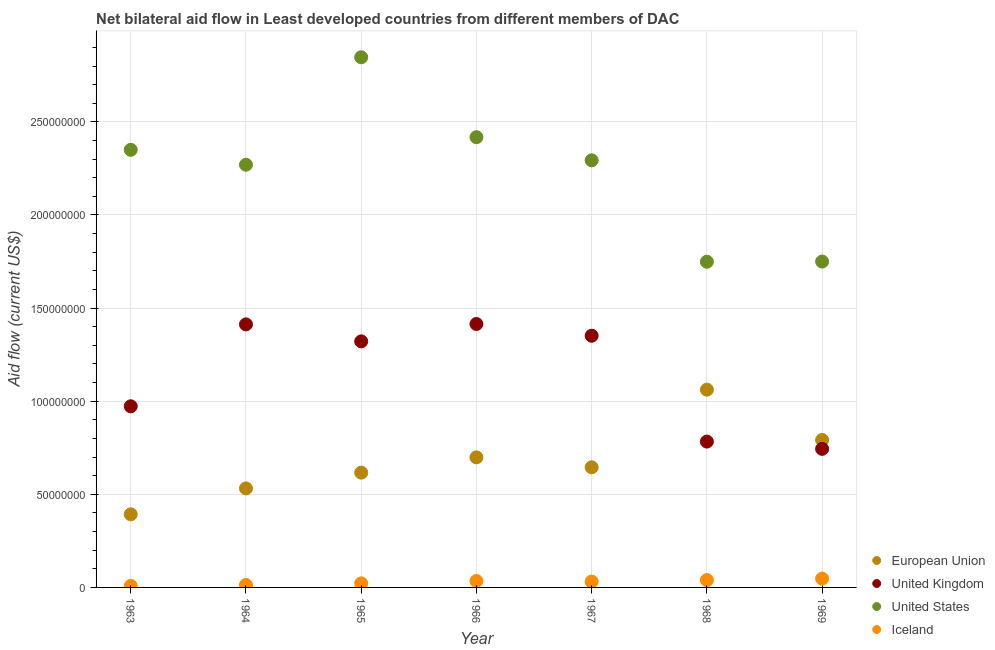What is the amount of aid given by uk in 1967?
Ensure brevity in your answer.  1.35e+08. Across all years, what is the maximum amount of aid given by iceland?
Keep it short and to the point. 4.74e+06. Across all years, what is the minimum amount of aid given by iceland?
Your response must be concise. 8.30e+05. In which year was the amount of aid given by us maximum?
Your answer should be compact. 1965. What is the total amount of aid given by us in the graph?
Provide a short and direct response. 1.57e+09. What is the difference between the amount of aid given by us in 1964 and that in 1969?
Make the answer very short. 5.20e+07. What is the difference between the amount of aid given by iceland in 1969 and the amount of aid given by uk in 1968?
Make the answer very short. -7.36e+07. What is the average amount of aid given by us per year?
Offer a terse response. 2.24e+08. In the year 1967, what is the difference between the amount of aid given by uk and amount of aid given by iceland?
Give a very brief answer. 1.32e+08. In how many years, is the amount of aid given by us greater than 130000000 US$?
Make the answer very short. 7. What is the ratio of the amount of aid given by uk in 1963 to that in 1968?
Your response must be concise. 1.24. What is the difference between the highest and the lowest amount of aid given by uk?
Offer a very short reply. 6.70e+07. In how many years, is the amount of aid given by uk greater than the average amount of aid given by uk taken over all years?
Your answer should be very brief. 4. Is the sum of the amount of aid given by eu in 1964 and 1969 greater than the maximum amount of aid given by iceland across all years?
Your answer should be very brief. Yes. Is it the case that in every year, the sum of the amount of aid given by eu and amount of aid given by uk is greater than the amount of aid given by us?
Your answer should be very brief. No. Does the amount of aid given by eu monotonically increase over the years?
Provide a succinct answer. No. Are the values on the major ticks of Y-axis written in scientific E-notation?
Your answer should be very brief. No. Where does the legend appear in the graph?
Offer a terse response. Bottom right. How many legend labels are there?
Provide a succinct answer. 4. What is the title of the graph?
Provide a short and direct response. Net bilateral aid flow in Least developed countries from different members of DAC. What is the label or title of the Y-axis?
Provide a short and direct response. Aid flow (current US$). What is the Aid flow (current US$) in European Union in 1963?
Your response must be concise. 3.93e+07. What is the Aid flow (current US$) of United Kingdom in 1963?
Your answer should be compact. 9.73e+07. What is the Aid flow (current US$) of United States in 1963?
Make the answer very short. 2.35e+08. What is the Aid flow (current US$) of Iceland in 1963?
Your answer should be very brief. 8.30e+05. What is the Aid flow (current US$) in European Union in 1964?
Your response must be concise. 5.32e+07. What is the Aid flow (current US$) in United Kingdom in 1964?
Provide a succinct answer. 1.41e+08. What is the Aid flow (current US$) in United States in 1964?
Give a very brief answer. 2.27e+08. What is the Aid flow (current US$) in Iceland in 1964?
Provide a succinct answer. 1.33e+06. What is the Aid flow (current US$) of European Union in 1965?
Offer a very short reply. 6.16e+07. What is the Aid flow (current US$) in United Kingdom in 1965?
Provide a succinct answer. 1.32e+08. What is the Aid flow (current US$) of United States in 1965?
Offer a very short reply. 2.85e+08. What is the Aid flow (current US$) of Iceland in 1965?
Your answer should be very brief. 2.18e+06. What is the Aid flow (current US$) of European Union in 1966?
Your answer should be compact. 6.99e+07. What is the Aid flow (current US$) in United Kingdom in 1966?
Offer a very short reply. 1.41e+08. What is the Aid flow (current US$) of United States in 1966?
Offer a very short reply. 2.42e+08. What is the Aid flow (current US$) of Iceland in 1966?
Offer a very short reply. 3.46e+06. What is the Aid flow (current US$) of European Union in 1967?
Keep it short and to the point. 6.45e+07. What is the Aid flow (current US$) in United Kingdom in 1967?
Give a very brief answer. 1.35e+08. What is the Aid flow (current US$) of United States in 1967?
Offer a very short reply. 2.29e+08. What is the Aid flow (current US$) in Iceland in 1967?
Your answer should be very brief. 3.12e+06. What is the Aid flow (current US$) of European Union in 1968?
Provide a succinct answer. 1.06e+08. What is the Aid flow (current US$) in United Kingdom in 1968?
Your answer should be very brief. 7.83e+07. What is the Aid flow (current US$) of United States in 1968?
Give a very brief answer. 1.75e+08. What is the Aid flow (current US$) in Iceland in 1968?
Offer a very short reply. 3.94e+06. What is the Aid flow (current US$) of European Union in 1969?
Ensure brevity in your answer.  7.92e+07. What is the Aid flow (current US$) of United Kingdom in 1969?
Make the answer very short. 7.44e+07. What is the Aid flow (current US$) in United States in 1969?
Your answer should be compact. 1.75e+08. What is the Aid flow (current US$) in Iceland in 1969?
Provide a succinct answer. 4.74e+06. Across all years, what is the maximum Aid flow (current US$) in European Union?
Provide a short and direct response. 1.06e+08. Across all years, what is the maximum Aid flow (current US$) in United Kingdom?
Provide a short and direct response. 1.41e+08. Across all years, what is the maximum Aid flow (current US$) of United States?
Provide a short and direct response. 2.85e+08. Across all years, what is the maximum Aid flow (current US$) in Iceland?
Provide a short and direct response. 4.74e+06. Across all years, what is the minimum Aid flow (current US$) in European Union?
Your answer should be very brief. 3.93e+07. Across all years, what is the minimum Aid flow (current US$) of United Kingdom?
Make the answer very short. 7.44e+07. Across all years, what is the minimum Aid flow (current US$) of United States?
Give a very brief answer. 1.75e+08. Across all years, what is the minimum Aid flow (current US$) in Iceland?
Your response must be concise. 8.30e+05. What is the total Aid flow (current US$) of European Union in the graph?
Your answer should be compact. 4.74e+08. What is the total Aid flow (current US$) of United Kingdom in the graph?
Provide a short and direct response. 8.00e+08. What is the total Aid flow (current US$) in United States in the graph?
Ensure brevity in your answer.  1.57e+09. What is the total Aid flow (current US$) in Iceland in the graph?
Offer a terse response. 1.96e+07. What is the difference between the Aid flow (current US$) of European Union in 1963 and that in 1964?
Ensure brevity in your answer.  -1.39e+07. What is the difference between the Aid flow (current US$) of United Kingdom in 1963 and that in 1964?
Provide a short and direct response. -4.40e+07. What is the difference between the Aid flow (current US$) in United States in 1963 and that in 1964?
Your answer should be compact. 8.00e+06. What is the difference between the Aid flow (current US$) of Iceland in 1963 and that in 1964?
Give a very brief answer. -5.00e+05. What is the difference between the Aid flow (current US$) of European Union in 1963 and that in 1965?
Offer a terse response. -2.24e+07. What is the difference between the Aid flow (current US$) in United Kingdom in 1963 and that in 1965?
Provide a short and direct response. -3.49e+07. What is the difference between the Aid flow (current US$) in United States in 1963 and that in 1965?
Make the answer very short. -4.97e+07. What is the difference between the Aid flow (current US$) of Iceland in 1963 and that in 1965?
Your answer should be very brief. -1.35e+06. What is the difference between the Aid flow (current US$) of European Union in 1963 and that in 1966?
Keep it short and to the point. -3.06e+07. What is the difference between the Aid flow (current US$) in United Kingdom in 1963 and that in 1966?
Offer a terse response. -4.42e+07. What is the difference between the Aid flow (current US$) of United States in 1963 and that in 1966?
Your answer should be very brief. -6.78e+06. What is the difference between the Aid flow (current US$) of Iceland in 1963 and that in 1966?
Make the answer very short. -2.63e+06. What is the difference between the Aid flow (current US$) of European Union in 1963 and that in 1967?
Your response must be concise. -2.52e+07. What is the difference between the Aid flow (current US$) of United Kingdom in 1963 and that in 1967?
Your response must be concise. -3.79e+07. What is the difference between the Aid flow (current US$) of United States in 1963 and that in 1967?
Offer a very short reply. 5.63e+06. What is the difference between the Aid flow (current US$) of Iceland in 1963 and that in 1967?
Make the answer very short. -2.29e+06. What is the difference between the Aid flow (current US$) in European Union in 1963 and that in 1968?
Provide a succinct answer. -6.69e+07. What is the difference between the Aid flow (current US$) of United Kingdom in 1963 and that in 1968?
Your answer should be compact. 1.90e+07. What is the difference between the Aid flow (current US$) of United States in 1963 and that in 1968?
Offer a very short reply. 6.01e+07. What is the difference between the Aid flow (current US$) in Iceland in 1963 and that in 1968?
Keep it short and to the point. -3.11e+06. What is the difference between the Aid flow (current US$) in European Union in 1963 and that in 1969?
Ensure brevity in your answer.  -3.99e+07. What is the difference between the Aid flow (current US$) of United Kingdom in 1963 and that in 1969?
Make the answer very short. 2.28e+07. What is the difference between the Aid flow (current US$) in United States in 1963 and that in 1969?
Ensure brevity in your answer.  6.00e+07. What is the difference between the Aid flow (current US$) of Iceland in 1963 and that in 1969?
Provide a short and direct response. -3.91e+06. What is the difference between the Aid flow (current US$) in European Union in 1964 and that in 1965?
Offer a terse response. -8.46e+06. What is the difference between the Aid flow (current US$) in United Kingdom in 1964 and that in 1965?
Give a very brief answer. 9.12e+06. What is the difference between the Aid flow (current US$) in United States in 1964 and that in 1965?
Give a very brief answer. -5.77e+07. What is the difference between the Aid flow (current US$) in Iceland in 1964 and that in 1965?
Your answer should be very brief. -8.50e+05. What is the difference between the Aid flow (current US$) of European Union in 1964 and that in 1966?
Provide a short and direct response. -1.67e+07. What is the difference between the Aid flow (current US$) of United States in 1964 and that in 1966?
Make the answer very short. -1.48e+07. What is the difference between the Aid flow (current US$) of Iceland in 1964 and that in 1966?
Provide a succinct answer. -2.13e+06. What is the difference between the Aid flow (current US$) of European Union in 1964 and that in 1967?
Ensure brevity in your answer.  -1.13e+07. What is the difference between the Aid flow (current US$) in United Kingdom in 1964 and that in 1967?
Provide a succinct answer. 6.10e+06. What is the difference between the Aid flow (current US$) in United States in 1964 and that in 1967?
Keep it short and to the point. -2.37e+06. What is the difference between the Aid flow (current US$) of Iceland in 1964 and that in 1967?
Offer a very short reply. -1.79e+06. What is the difference between the Aid flow (current US$) of European Union in 1964 and that in 1968?
Your answer should be compact. -5.30e+07. What is the difference between the Aid flow (current US$) of United Kingdom in 1964 and that in 1968?
Offer a very short reply. 6.29e+07. What is the difference between the Aid flow (current US$) in United States in 1964 and that in 1968?
Give a very brief answer. 5.21e+07. What is the difference between the Aid flow (current US$) of Iceland in 1964 and that in 1968?
Provide a short and direct response. -2.61e+06. What is the difference between the Aid flow (current US$) in European Union in 1964 and that in 1969?
Ensure brevity in your answer.  -2.60e+07. What is the difference between the Aid flow (current US$) of United Kingdom in 1964 and that in 1969?
Your answer should be very brief. 6.68e+07. What is the difference between the Aid flow (current US$) in United States in 1964 and that in 1969?
Your answer should be very brief. 5.20e+07. What is the difference between the Aid flow (current US$) of Iceland in 1964 and that in 1969?
Make the answer very short. -3.41e+06. What is the difference between the Aid flow (current US$) of European Union in 1965 and that in 1966?
Your answer should be compact. -8.22e+06. What is the difference between the Aid flow (current US$) of United Kingdom in 1965 and that in 1966?
Your answer should be compact. -9.33e+06. What is the difference between the Aid flow (current US$) in United States in 1965 and that in 1966?
Offer a terse response. 4.29e+07. What is the difference between the Aid flow (current US$) in Iceland in 1965 and that in 1966?
Make the answer very short. -1.28e+06. What is the difference between the Aid flow (current US$) of European Union in 1965 and that in 1967?
Give a very brief answer. -2.87e+06. What is the difference between the Aid flow (current US$) of United Kingdom in 1965 and that in 1967?
Your answer should be compact. -3.02e+06. What is the difference between the Aid flow (current US$) of United States in 1965 and that in 1967?
Provide a short and direct response. 5.53e+07. What is the difference between the Aid flow (current US$) in Iceland in 1965 and that in 1967?
Provide a short and direct response. -9.40e+05. What is the difference between the Aid flow (current US$) in European Union in 1965 and that in 1968?
Offer a terse response. -4.46e+07. What is the difference between the Aid flow (current US$) in United Kingdom in 1965 and that in 1968?
Your response must be concise. 5.38e+07. What is the difference between the Aid flow (current US$) of United States in 1965 and that in 1968?
Keep it short and to the point. 1.10e+08. What is the difference between the Aid flow (current US$) of Iceland in 1965 and that in 1968?
Offer a terse response. -1.76e+06. What is the difference between the Aid flow (current US$) in European Union in 1965 and that in 1969?
Provide a succinct answer. -1.75e+07. What is the difference between the Aid flow (current US$) of United Kingdom in 1965 and that in 1969?
Provide a short and direct response. 5.77e+07. What is the difference between the Aid flow (current US$) in United States in 1965 and that in 1969?
Give a very brief answer. 1.10e+08. What is the difference between the Aid flow (current US$) of Iceland in 1965 and that in 1969?
Your response must be concise. -2.56e+06. What is the difference between the Aid flow (current US$) of European Union in 1966 and that in 1967?
Your answer should be compact. 5.35e+06. What is the difference between the Aid flow (current US$) of United Kingdom in 1966 and that in 1967?
Provide a short and direct response. 6.31e+06. What is the difference between the Aid flow (current US$) in United States in 1966 and that in 1967?
Your response must be concise. 1.24e+07. What is the difference between the Aid flow (current US$) in Iceland in 1966 and that in 1967?
Provide a short and direct response. 3.40e+05. What is the difference between the Aid flow (current US$) in European Union in 1966 and that in 1968?
Offer a very short reply. -3.63e+07. What is the difference between the Aid flow (current US$) in United Kingdom in 1966 and that in 1968?
Your answer should be compact. 6.32e+07. What is the difference between the Aid flow (current US$) of United States in 1966 and that in 1968?
Provide a short and direct response. 6.69e+07. What is the difference between the Aid flow (current US$) in Iceland in 1966 and that in 1968?
Offer a very short reply. -4.80e+05. What is the difference between the Aid flow (current US$) of European Union in 1966 and that in 1969?
Your answer should be compact. -9.32e+06. What is the difference between the Aid flow (current US$) of United Kingdom in 1966 and that in 1969?
Your answer should be very brief. 6.70e+07. What is the difference between the Aid flow (current US$) in United States in 1966 and that in 1969?
Ensure brevity in your answer.  6.68e+07. What is the difference between the Aid flow (current US$) in Iceland in 1966 and that in 1969?
Provide a succinct answer. -1.28e+06. What is the difference between the Aid flow (current US$) of European Union in 1967 and that in 1968?
Your answer should be very brief. -4.17e+07. What is the difference between the Aid flow (current US$) of United Kingdom in 1967 and that in 1968?
Keep it short and to the point. 5.68e+07. What is the difference between the Aid flow (current US$) in United States in 1967 and that in 1968?
Provide a succinct answer. 5.45e+07. What is the difference between the Aid flow (current US$) of Iceland in 1967 and that in 1968?
Ensure brevity in your answer.  -8.20e+05. What is the difference between the Aid flow (current US$) of European Union in 1967 and that in 1969?
Your response must be concise. -1.47e+07. What is the difference between the Aid flow (current US$) in United Kingdom in 1967 and that in 1969?
Offer a very short reply. 6.07e+07. What is the difference between the Aid flow (current US$) of United States in 1967 and that in 1969?
Provide a short and direct response. 5.44e+07. What is the difference between the Aid flow (current US$) of Iceland in 1967 and that in 1969?
Provide a short and direct response. -1.62e+06. What is the difference between the Aid flow (current US$) in European Union in 1968 and that in 1969?
Ensure brevity in your answer.  2.70e+07. What is the difference between the Aid flow (current US$) of United Kingdom in 1968 and that in 1969?
Ensure brevity in your answer.  3.90e+06. What is the difference between the Aid flow (current US$) in United States in 1968 and that in 1969?
Make the answer very short. -1.00e+05. What is the difference between the Aid flow (current US$) of Iceland in 1968 and that in 1969?
Make the answer very short. -8.00e+05. What is the difference between the Aid flow (current US$) in European Union in 1963 and the Aid flow (current US$) in United Kingdom in 1964?
Your response must be concise. -1.02e+08. What is the difference between the Aid flow (current US$) in European Union in 1963 and the Aid flow (current US$) in United States in 1964?
Offer a very short reply. -1.88e+08. What is the difference between the Aid flow (current US$) of European Union in 1963 and the Aid flow (current US$) of Iceland in 1964?
Make the answer very short. 3.79e+07. What is the difference between the Aid flow (current US$) in United Kingdom in 1963 and the Aid flow (current US$) in United States in 1964?
Offer a very short reply. -1.30e+08. What is the difference between the Aid flow (current US$) of United Kingdom in 1963 and the Aid flow (current US$) of Iceland in 1964?
Ensure brevity in your answer.  9.59e+07. What is the difference between the Aid flow (current US$) of United States in 1963 and the Aid flow (current US$) of Iceland in 1964?
Keep it short and to the point. 2.34e+08. What is the difference between the Aid flow (current US$) of European Union in 1963 and the Aid flow (current US$) of United Kingdom in 1965?
Your answer should be very brief. -9.29e+07. What is the difference between the Aid flow (current US$) of European Union in 1963 and the Aid flow (current US$) of United States in 1965?
Your answer should be very brief. -2.45e+08. What is the difference between the Aid flow (current US$) in European Union in 1963 and the Aid flow (current US$) in Iceland in 1965?
Give a very brief answer. 3.71e+07. What is the difference between the Aid flow (current US$) of United Kingdom in 1963 and the Aid flow (current US$) of United States in 1965?
Give a very brief answer. -1.87e+08. What is the difference between the Aid flow (current US$) of United Kingdom in 1963 and the Aid flow (current US$) of Iceland in 1965?
Offer a terse response. 9.51e+07. What is the difference between the Aid flow (current US$) of United States in 1963 and the Aid flow (current US$) of Iceland in 1965?
Your answer should be compact. 2.33e+08. What is the difference between the Aid flow (current US$) of European Union in 1963 and the Aid flow (current US$) of United Kingdom in 1966?
Make the answer very short. -1.02e+08. What is the difference between the Aid flow (current US$) in European Union in 1963 and the Aid flow (current US$) in United States in 1966?
Your answer should be very brief. -2.03e+08. What is the difference between the Aid flow (current US$) in European Union in 1963 and the Aid flow (current US$) in Iceland in 1966?
Offer a very short reply. 3.58e+07. What is the difference between the Aid flow (current US$) in United Kingdom in 1963 and the Aid flow (current US$) in United States in 1966?
Your response must be concise. -1.45e+08. What is the difference between the Aid flow (current US$) in United Kingdom in 1963 and the Aid flow (current US$) in Iceland in 1966?
Provide a succinct answer. 9.38e+07. What is the difference between the Aid flow (current US$) of United States in 1963 and the Aid flow (current US$) of Iceland in 1966?
Keep it short and to the point. 2.32e+08. What is the difference between the Aid flow (current US$) in European Union in 1963 and the Aid flow (current US$) in United Kingdom in 1967?
Your response must be concise. -9.59e+07. What is the difference between the Aid flow (current US$) of European Union in 1963 and the Aid flow (current US$) of United States in 1967?
Your answer should be compact. -1.90e+08. What is the difference between the Aid flow (current US$) in European Union in 1963 and the Aid flow (current US$) in Iceland in 1967?
Keep it short and to the point. 3.61e+07. What is the difference between the Aid flow (current US$) of United Kingdom in 1963 and the Aid flow (current US$) of United States in 1967?
Your answer should be very brief. -1.32e+08. What is the difference between the Aid flow (current US$) of United Kingdom in 1963 and the Aid flow (current US$) of Iceland in 1967?
Provide a short and direct response. 9.42e+07. What is the difference between the Aid flow (current US$) of United States in 1963 and the Aid flow (current US$) of Iceland in 1967?
Ensure brevity in your answer.  2.32e+08. What is the difference between the Aid flow (current US$) of European Union in 1963 and the Aid flow (current US$) of United Kingdom in 1968?
Ensure brevity in your answer.  -3.91e+07. What is the difference between the Aid flow (current US$) in European Union in 1963 and the Aid flow (current US$) in United States in 1968?
Offer a very short reply. -1.36e+08. What is the difference between the Aid flow (current US$) in European Union in 1963 and the Aid flow (current US$) in Iceland in 1968?
Offer a terse response. 3.53e+07. What is the difference between the Aid flow (current US$) of United Kingdom in 1963 and the Aid flow (current US$) of United States in 1968?
Offer a very short reply. -7.76e+07. What is the difference between the Aid flow (current US$) of United Kingdom in 1963 and the Aid flow (current US$) of Iceland in 1968?
Ensure brevity in your answer.  9.33e+07. What is the difference between the Aid flow (current US$) of United States in 1963 and the Aid flow (current US$) of Iceland in 1968?
Offer a very short reply. 2.31e+08. What is the difference between the Aid flow (current US$) of European Union in 1963 and the Aid flow (current US$) of United Kingdom in 1969?
Offer a very short reply. -3.52e+07. What is the difference between the Aid flow (current US$) of European Union in 1963 and the Aid flow (current US$) of United States in 1969?
Make the answer very short. -1.36e+08. What is the difference between the Aid flow (current US$) of European Union in 1963 and the Aid flow (current US$) of Iceland in 1969?
Provide a succinct answer. 3.45e+07. What is the difference between the Aid flow (current US$) in United Kingdom in 1963 and the Aid flow (current US$) in United States in 1969?
Your answer should be compact. -7.77e+07. What is the difference between the Aid flow (current US$) in United Kingdom in 1963 and the Aid flow (current US$) in Iceland in 1969?
Keep it short and to the point. 9.25e+07. What is the difference between the Aid flow (current US$) in United States in 1963 and the Aid flow (current US$) in Iceland in 1969?
Your answer should be very brief. 2.30e+08. What is the difference between the Aid flow (current US$) in European Union in 1964 and the Aid flow (current US$) in United Kingdom in 1965?
Provide a succinct answer. -7.90e+07. What is the difference between the Aid flow (current US$) of European Union in 1964 and the Aid flow (current US$) of United States in 1965?
Your response must be concise. -2.32e+08. What is the difference between the Aid flow (current US$) of European Union in 1964 and the Aid flow (current US$) of Iceland in 1965?
Provide a succinct answer. 5.10e+07. What is the difference between the Aid flow (current US$) in United Kingdom in 1964 and the Aid flow (current US$) in United States in 1965?
Keep it short and to the point. -1.43e+08. What is the difference between the Aid flow (current US$) of United Kingdom in 1964 and the Aid flow (current US$) of Iceland in 1965?
Your answer should be very brief. 1.39e+08. What is the difference between the Aid flow (current US$) of United States in 1964 and the Aid flow (current US$) of Iceland in 1965?
Keep it short and to the point. 2.25e+08. What is the difference between the Aid flow (current US$) in European Union in 1964 and the Aid flow (current US$) in United Kingdom in 1966?
Provide a short and direct response. -8.83e+07. What is the difference between the Aid flow (current US$) in European Union in 1964 and the Aid flow (current US$) in United States in 1966?
Offer a terse response. -1.89e+08. What is the difference between the Aid flow (current US$) in European Union in 1964 and the Aid flow (current US$) in Iceland in 1966?
Provide a short and direct response. 4.97e+07. What is the difference between the Aid flow (current US$) of United Kingdom in 1964 and the Aid flow (current US$) of United States in 1966?
Your answer should be compact. -1.01e+08. What is the difference between the Aid flow (current US$) of United Kingdom in 1964 and the Aid flow (current US$) of Iceland in 1966?
Offer a very short reply. 1.38e+08. What is the difference between the Aid flow (current US$) in United States in 1964 and the Aid flow (current US$) in Iceland in 1966?
Your answer should be compact. 2.24e+08. What is the difference between the Aid flow (current US$) in European Union in 1964 and the Aid flow (current US$) in United Kingdom in 1967?
Provide a short and direct response. -8.20e+07. What is the difference between the Aid flow (current US$) of European Union in 1964 and the Aid flow (current US$) of United States in 1967?
Your answer should be compact. -1.76e+08. What is the difference between the Aid flow (current US$) in European Union in 1964 and the Aid flow (current US$) in Iceland in 1967?
Offer a very short reply. 5.01e+07. What is the difference between the Aid flow (current US$) of United Kingdom in 1964 and the Aid flow (current US$) of United States in 1967?
Provide a succinct answer. -8.81e+07. What is the difference between the Aid flow (current US$) in United Kingdom in 1964 and the Aid flow (current US$) in Iceland in 1967?
Ensure brevity in your answer.  1.38e+08. What is the difference between the Aid flow (current US$) of United States in 1964 and the Aid flow (current US$) of Iceland in 1967?
Make the answer very short. 2.24e+08. What is the difference between the Aid flow (current US$) in European Union in 1964 and the Aid flow (current US$) in United Kingdom in 1968?
Offer a terse response. -2.51e+07. What is the difference between the Aid flow (current US$) of European Union in 1964 and the Aid flow (current US$) of United States in 1968?
Offer a very short reply. -1.22e+08. What is the difference between the Aid flow (current US$) in European Union in 1964 and the Aid flow (current US$) in Iceland in 1968?
Your answer should be compact. 4.92e+07. What is the difference between the Aid flow (current US$) in United Kingdom in 1964 and the Aid flow (current US$) in United States in 1968?
Make the answer very short. -3.36e+07. What is the difference between the Aid flow (current US$) of United Kingdom in 1964 and the Aid flow (current US$) of Iceland in 1968?
Offer a terse response. 1.37e+08. What is the difference between the Aid flow (current US$) of United States in 1964 and the Aid flow (current US$) of Iceland in 1968?
Provide a short and direct response. 2.23e+08. What is the difference between the Aid flow (current US$) in European Union in 1964 and the Aid flow (current US$) in United Kingdom in 1969?
Your answer should be compact. -2.12e+07. What is the difference between the Aid flow (current US$) in European Union in 1964 and the Aid flow (current US$) in United States in 1969?
Offer a terse response. -1.22e+08. What is the difference between the Aid flow (current US$) of European Union in 1964 and the Aid flow (current US$) of Iceland in 1969?
Your answer should be very brief. 4.84e+07. What is the difference between the Aid flow (current US$) in United Kingdom in 1964 and the Aid flow (current US$) in United States in 1969?
Offer a terse response. -3.37e+07. What is the difference between the Aid flow (current US$) of United Kingdom in 1964 and the Aid flow (current US$) of Iceland in 1969?
Make the answer very short. 1.37e+08. What is the difference between the Aid flow (current US$) in United States in 1964 and the Aid flow (current US$) in Iceland in 1969?
Give a very brief answer. 2.22e+08. What is the difference between the Aid flow (current US$) of European Union in 1965 and the Aid flow (current US$) of United Kingdom in 1966?
Ensure brevity in your answer.  -7.98e+07. What is the difference between the Aid flow (current US$) in European Union in 1965 and the Aid flow (current US$) in United States in 1966?
Your answer should be compact. -1.80e+08. What is the difference between the Aid flow (current US$) in European Union in 1965 and the Aid flow (current US$) in Iceland in 1966?
Your response must be concise. 5.82e+07. What is the difference between the Aid flow (current US$) in United Kingdom in 1965 and the Aid flow (current US$) in United States in 1966?
Offer a terse response. -1.10e+08. What is the difference between the Aid flow (current US$) in United Kingdom in 1965 and the Aid flow (current US$) in Iceland in 1966?
Your answer should be compact. 1.29e+08. What is the difference between the Aid flow (current US$) in United States in 1965 and the Aid flow (current US$) in Iceland in 1966?
Ensure brevity in your answer.  2.81e+08. What is the difference between the Aid flow (current US$) of European Union in 1965 and the Aid flow (current US$) of United Kingdom in 1967?
Provide a succinct answer. -7.35e+07. What is the difference between the Aid flow (current US$) of European Union in 1965 and the Aid flow (current US$) of United States in 1967?
Ensure brevity in your answer.  -1.68e+08. What is the difference between the Aid flow (current US$) of European Union in 1965 and the Aid flow (current US$) of Iceland in 1967?
Your answer should be very brief. 5.85e+07. What is the difference between the Aid flow (current US$) of United Kingdom in 1965 and the Aid flow (current US$) of United States in 1967?
Keep it short and to the point. -9.72e+07. What is the difference between the Aid flow (current US$) of United Kingdom in 1965 and the Aid flow (current US$) of Iceland in 1967?
Give a very brief answer. 1.29e+08. What is the difference between the Aid flow (current US$) in United States in 1965 and the Aid flow (current US$) in Iceland in 1967?
Give a very brief answer. 2.82e+08. What is the difference between the Aid flow (current US$) of European Union in 1965 and the Aid flow (current US$) of United Kingdom in 1968?
Give a very brief answer. -1.67e+07. What is the difference between the Aid flow (current US$) in European Union in 1965 and the Aid flow (current US$) in United States in 1968?
Provide a succinct answer. -1.13e+08. What is the difference between the Aid flow (current US$) in European Union in 1965 and the Aid flow (current US$) in Iceland in 1968?
Keep it short and to the point. 5.77e+07. What is the difference between the Aid flow (current US$) of United Kingdom in 1965 and the Aid flow (current US$) of United States in 1968?
Offer a very short reply. -4.28e+07. What is the difference between the Aid flow (current US$) in United Kingdom in 1965 and the Aid flow (current US$) in Iceland in 1968?
Make the answer very short. 1.28e+08. What is the difference between the Aid flow (current US$) of United States in 1965 and the Aid flow (current US$) of Iceland in 1968?
Your response must be concise. 2.81e+08. What is the difference between the Aid flow (current US$) of European Union in 1965 and the Aid flow (current US$) of United Kingdom in 1969?
Offer a very short reply. -1.28e+07. What is the difference between the Aid flow (current US$) of European Union in 1965 and the Aid flow (current US$) of United States in 1969?
Provide a succinct answer. -1.13e+08. What is the difference between the Aid flow (current US$) of European Union in 1965 and the Aid flow (current US$) of Iceland in 1969?
Give a very brief answer. 5.69e+07. What is the difference between the Aid flow (current US$) in United Kingdom in 1965 and the Aid flow (current US$) in United States in 1969?
Ensure brevity in your answer.  -4.29e+07. What is the difference between the Aid flow (current US$) of United Kingdom in 1965 and the Aid flow (current US$) of Iceland in 1969?
Keep it short and to the point. 1.27e+08. What is the difference between the Aid flow (current US$) of United States in 1965 and the Aid flow (current US$) of Iceland in 1969?
Your answer should be very brief. 2.80e+08. What is the difference between the Aid flow (current US$) of European Union in 1966 and the Aid flow (current US$) of United Kingdom in 1967?
Your response must be concise. -6.53e+07. What is the difference between the Aid flow (current US$) of European Union in 1966 and the Aid flow (current US$) of United States in 1967?
Keep it short and to the point. -1.60e+08. What is the difference between the Aid flow (current US$) in European Union in 1966 and the Aid flow (current US$) in Iceland in 1967?
Keep it short and to the point. 6.67e+07. What is the difference between the Aid flow (current US$) in United Kingdom in 1966 and the Aid flow (current US$) in United States in 1967?
Your answer should be compact. -8.79e+07. What is the difference between the Aid flow (current US$) of United Kingdom in 1966 and the Aid flow (current US$) of Iceland in 1967?
Ensure brevity in your answer.  1.38e+08. What is the difference between the Aid flow (current US$) of United States in 1966 and the Aid flow (current US$) of Iceland in 1967?
Ensure brevity in your answer.  2.39e+08. What is the difference between the Aid flow (current US$) of European Union in 1966 and the Aid flow (current US$) of United Kingdom in 1968?
Offer a terse response. -8.46e+06. What is the difference between the Aid flow (current US$) of European Union in 1966 and the Aid flow (current US$) of United States in 1968?
Offer a very short reply. -1.05e+08. What is the difference between the Aid flow (current US$) of European Union in 1966 and the Aid flow (current US$) of Iceland in 1968?
Your answer should be very brief. 6.59e+07. What is the difference between the Aid flow (current US$) in United Kingdom in 1966 and the Aid flow (current US$) in United States in 1968?
Offer a terse response. -3.34e+07. What is the difference between the Aid flow (current US$) of United Kingdom in 1966 and the Aid flow (current US$) of Iceland in 1968?
Ensure brevity in your answer.  1.38e+08. What is the difference between the Aid flow (current US$) in United States in 1966 and the Aid flow (current US$) in Iceland in 1968?
Your answer should be very brief. 2.38e+08. What is the difference between the Aid flow (current US$) in European Union in 1966 and the Aid flow (current US$) in United Kingdom in 1969?
Make the answer very short. -4.56e+06. What is the difference between the Aid flow (current US$) in European Union in 1966 and the Aid flow (current US$) in United States in 1969?
Provide a succinct answer. -1.05e+08. What is the difference between the Aid flow (current US$) in European Union in 1966 and the Aid flow (current US$) in Iceland in 1969?
Provide a short and direct response. 6.51e+07. What is the difference between the Aid flow (current US$) of United Kingdom in 1966 and the Aid flow (current US$) of United States in 1969?
Provide a succinct answer. -3.35e+07. What is the difference between the Aid flow (current US$) of United Kingdom in 1966 and the Aid flow (current US$) of Iceland in 1969?
Provide a succinct answer. 1.37e+08. What is the difference between the Aid flow (current US$) in United States in 1966 and the Aid flow (current US$) in Iceland in 1969?
Offer a very short reply. 2.37e+08. What is the difference between the Aid flow (current US$) of European Union in 1967 and the Aid flow (current US$) of United Kingdom in 1968?
Provide a short and direct response. -1.38e+07. What is the difference between the Aid flow (current US$) in European Union in 1967 and the Aid flow (current US$) in United States in 1968?
Provide a short and direct response. -1.10e+08. What is the difference between the Aid flow (current US$) of European Union in 1967 and the Aid flow (current US$) of Iceland in 1968?
Provide a succinct answer. 6.06e+07. What is the difference between the Aid flow (current US$) in United Kingdom in 1967 and the Aid flow (current US$) in United States in 1968?
Your answer should be compact. -3.97e+07. What is the difference between the Aid flow (current US$) in United Kingdom in 1967 and the Aid flow (current US$) in Iceland in 1968?
Offer a very short reply. 1.31e+08. What is the difference between the Aid flow (current US$) of United States in 1967 and the Aid flow (current US$) of Iceland in 1968?
Make the answer very short. 2.25e+08. What is the difference between the Aid flow (current US$) of European Union in 1967 and the Aid flow (current US$) of United Kingdom in 1969?
Your response must be concise. -9.91e+06. What is the difference between the Aid flow (current US$) in European Union in 1967 and the Aid flow (current US$) in United States in 1969?
Keep it short and to the point. -1.10e+08. What is the difference between the Aid flow (current US$) in European Union in 1967 and the Aid flow (current US$) in Iceland in 1969?
Provide a succinct answer. 5.98e+07. What is the difference between the Aid flow (current US$) of United Kingdom in 1967 and the Aid flow (current US$) of United States in 1969?
Provide a succinct answer. -3.98e+07. What is the difference between the Aid flow (current US$) of United Kingdom in 1967 and the Aid flow (current US$) of Iceland in 1969?
Your answer should be very brief. 1.30e+08. What is the difference between the Aid flow (current US$) of United States in 1967 and the Aid flow (current US$) of Iceland in 1969?
Provide a short and direct response. 2.25e+08. What is the difference between the Aid flow (current US$) of European Union in 1968 and the Aid flow (current US$) of United Kingdom in 1969?
Your response must be concise. 3.18e+07. What is the difference between the Aid flow (current US$) in European Union in 1968 and the Aid flow (current US$) in United States in 1969?
Provide a short and direct response. -6.88e+07. What is the difference between the Aid flow (current US$) in European Union in 1968 and the Aid flow (current US$) in Iceland in 1969?
Offer a terse response. 1.01e+08. What is the difference between the Aid flow (current US$) in United Kingdom in 1968 and the Aid flow (current US$) in United States in 1969?
Ensure brevity in your answer.  -9.67e+07. What is the difference between the Aid flow (current US$) of United Kingdom in 1968 and the Aid flow (current US$) of Iceland in 1969?
Provide a succinct answer. 7.36e+07. What is the difference between the Aid flow (current US$) in United States in 1968 and the Aid flow (current US$) in Iceland in 1969?
Your response must be concise. 1.70e+08. What is the average Aid flow (current US$) of European Union per year?
Your response must be concise. 6.77e+07. What is the average Aid flow (current US$) of United Kingdom per year?
Offer a terse response. 1.14e+08. What is the average Aid flow (current US$) of United States per year?
Make the answer very short. 2.24e+08. What is the average Aid flow (current US$) in Iceland per year?
Your response must be concise. 2.80e+06. In the year 1963, what is the difference between the Aid flow (current US$) in European Union and Aid flow (current US$) in United Kingdom?
Offer a terse response. -5.80e+07. In the year 1963, what is the difference between the Aid flow (current US$) of European Union and Aid flow (current US$) of United States?
Your answer should be very brief. -1.96e+08. In the year 1963, what is the difference between the Aid flow (current US$) in European Union and Aid flow (current US$) in Iceland?
Make the answer very short. 3.84e+07. In the year 1963, what is the difference between the Aid flow (current US$) of United Kingdom and Aid flow (current US$) of United States?
Keep it short and to the point. -1.38e+08. In the year 1963, what is the difference between the Aid flow (current US$) in United Kingdom and Aid flow (current US$) in Iceland?
Provide a succinct answer. 9.64e+07. In the year 1963, what is the difference between the Aid flow (current US$) in United States and Aid flow (current US$) in Iceland?
Provide a short and direct response. 2.34e+08. In the year 1964, what is the difference between the Aid flow (current US$) in European Union and Aid flow (current US$) in United Kingdom?
Offer a terse response. -8.81e+07. In the year 1964, what is the difference between the Aid flow (current US$) in European Union and Aid flow (current US$) in United States?
Keep it short and to the point. -1.74e+08. In the year 1964, what is the difference between the Aid flow (current US$) of European Union and Aid flow (current US$) of Iceland?
Offer a very short reply. 5.18e+07. In the year 1964, what is the difference between the Aid flow (current US$) of United Kingdom and Aid flow (current US$) of United States?
Provide a short and direct response. -8.57e+07. In the year 1964, what is the difference between the Aid flow (current US$) of United Kingdom and Aid flow (current US$) of Iceland?
Provide a short and direct response. 1.40e+08. In the year 1964, what is the difference between the Aid flow (current US$) in United States and Aid flow (current US$) in Iceland?
Ensure brevity in your answer.  2.26e+08. In the year 1965, what is the difference between the Aid flow (current US$) in European Union and Aid flow (current US$) in United Kingdom?
Keep it short and to the point. -7.05e+07. In the year 1965, what is the difference between the Aid flow (current US$) of European Union and Aid flow (current US$) of United States?
Make the answer very short. -2.23e+08. In the year 1965, what is the difference between the Aid flow (current US$) of European Union and Aid flow (current US$) of Iceland?
Make the answer very short. 5.95e+07. In the year 1965, what is the difference between the Aid flow (current US$) in United Kingdom and Aid flow (current US$) in United States?
Provide a short and direct response. -1.53e+08. In the year 1965, what is the difference between the Aid flow (current US$) of United Kingdom and Aid flow (current US$) of Iceland?
Keep it short and to the point. 1.30e+08. In the year 1965, what is the difference between the Aid flow (current US$) of United States and Aid flow (current US$) of Iceland?
Provide a short and direct response. 2.83e+08. In the year 1966, what is the difference between the Aid flow (current US$) in European Union and Aid flow (current US$) in United Kingdom?
Give a very brief answer. -7.16e+07. In the year 1966, what is the difference between the Aid flow (current US$) in European Union and Aid flow (current US$) in United States?
Provide a succinct answer. -1.72e+08. In the year 1966, what is the difference between the Aid flow (current US$) of European Union and Aid flow (current US$) of Iceland?
Make the answer very short. 6.64e+07. In the year 1966, what is the difference between the Aid flow (current US$) of United Kingdom and Aid flow (current US$) of United States?
Provide a short and direct response. -1.00e+08. In the year 1966, what is the difference between the Aid flow (current US$) in United Kingdom and Aid flow (current US$) in Iceland?
Your response must be concise. 1.38e+08. In the year 1966, what is the difference between the Aid flow (current US$) of United States and Aid flow (current US$) of Iceland?
Keep it short and to the point. 2.38e+08. In the year 1967, what is the difference between the Aid flow (current US$) in European Union and Aid flow (current US$) in United Kingdom?
Your answer should be very brief. -7.06e+07. In the year 1967, what is the difference between the Aid flow (current US$) of European Union and Aid flow (current US$) of United States?
Make the answer very short. -1.65e+08. In the year 1967, what is the difference between the Aid flow (current US$) in European Union and Aid flow (current US$) in Iceland?
Your response must be concise. 6.14e+07. In the year 1967, what is the difference between the Aid flow (current US$) in United Kingdom and Aid flow (current US$) in United States?
Ensure brevity in your answer.  -9.42e+07. In the year 1967, what is the difference between the Aid flow (current US$) in United Kingdom and Aid flow (current US$) in Iceland?
Offer a very short reply. 1.32e+08. In the year 1967, what is the difference between the Aid flow (current US$) in United States and Aid flow (current US$) in Iceland?
Your answer should be compact. 2.26e+08. In the year 1968, what is the difference between the Aid flow (current US$) in European Union and Aid flow (current US$) in United Kingdom?
Your answer should be very brief. 2.79e+07. In the year 1968, what is the difference between the Aid flow (current US$) in European Union and Aid flow (current US$) in United States?
Make the answer very short. -6.87e+07. In the year 1968, what is the difference between the Aid flow (current US$) in European Union and Aid flow (current US$) in Iceland?
Your answer should be very brief. 1.02e+08. In the year 1968, what is the difference between the Aid flow (current US$) of United Kingdom and Aid flow (current US$) of United States?
Make the answer very short. -9.66e+07. In the year 1968, what is the difference between the Aid flow (current US$) in United Kingdom and Aid flow (current US$) in Iceland?
Give a very brief answer. 7.44e+07. In the year 1968, what is the difference between the Aid flow (current US$) of United States and Aid flow (current US$) of Iceland?
Offer a very short reply. 1.71e+08. In the year 1969, what is the difference between the Aid flow (current US$) in European Union and Aid flow (current US$) in United Kingdom?
Offer a very short reply. 4.76e+06. In the year 1969, what is the difference between the Aid flow (current US$) of European Union and Aid flow (current US$) of United States?
Provide a succinct answer. -9.58e+07. In the year 1969, what is the difference between the Aid flow (current US$) of European Union and Aid flow (current US$) of Iceland?
Ensure brevity in your answer.  7.44e+07. In the year 1969, what is the difference between the Aid flow (current US$) in United Kingdom and Aid flow (current US$) in United States?
Give a very brief answer. -1.01e+08. In the year 1969, what is the difference between the Aid flow (current US$) in United Kingdom and Aid flow (current US$) in Iceland?
Keep it short and to the point. 6.97e+07. In the year 1969, what is the difference between the Aid flow (current US$) of United States and Aid flow (current US$) of Iceland?
Give a very brief answer. 1.70e+08. What is the ratio of the Aid flow (current US$) of European Union in 1963 to that in 1964?
Your answer should be compact. 0.74. What is the ratio of the Aid flow (current US$) in United Kingdom in 1963 to that in 1964?
Provide a succinct answer. 0.69. What is the ratio of the Aid flow (current US$) in United States in 1963 to that in 1964?
Your response must be concise. 1.04. What is the ratio of the Aid flow (current US$) of Iceland in 1963 to that in 1964?
Make the answer very short. 0.62. What is the ratio of the Aid flow (current US$) in European Union in 1963 to that in 1965?
Offer a terse response. 0.64. What is the ratio of the Aid flow (current US$) in United Kingdom in 1963 to that in 1965?
Keep it short and to the point. 0.74. What is the ratio of the Aid flow (current US$) of United States in 1963 to that in 1965?
Offer a terse response. 0.83. What is the ratio of the Aid flow (current US$) of Iceland in 1963 to that in 1965?
Offer a very short reply. 0.38. What is the ratio of the Aid flow (current US$) in European Union in 1963 to that in 1966?
Ensure brevity in your answer.  0.56. What is the ratio of the Aid flow (current US$) in United Kingdom in 1963 to that in 1966?
Your answer should be very brief. 0.69. What is the ratio of the Aid flow (current US$) in United States in 1963 to that in 1966?
Your answer should be compact. 0.97. What is the ratio of the Aid flow (current US$) of Iceland in 1963 to that in 1966?
Your answer should be very brief. 0.24. What is the ratio of the Aid flow (current US$) of European Union in 1963 to that in 1967?
Ensure brevity in your answer.  0.61. What is the ratio of the Aid flow (current US$) of United Kingdom in 1963 to that in 1967?
Keep it short and to the point. 0.72. What is the ratio of the Aid flow (current US$) of United States in 1963 to that in 1967?
Keep it short and to the point. 1.02. What is the ratio of the Aid flow (current US$) in Iceland in 1963 to that in 1967?
Give a very brief answer. 0.27. What is the ratio of the Aid flow (current US$) of European Union in 1963 to that in 1968?
Your answer should be compact. 0.37. What is the ratio of the Aid flow (current US$) of United Kingdom in 1963 to that in 1968?
Provide a succinct answer. 1.24. What is the ratio of the Aid flow (current US$) of United States in 1963 to that in 1968?
Offer a terse response. 1.34. What is the ratio of the Aid flow (current US$) in Iceland in 1963 to that in 1968?
Ensure brevity in your answer.  0.21. What is the ratio of the Aid flow (current US$) of European Union in 1963 to that in 1969?
Your answer should be compact. 0.5. What is the ratio of the Aid flow (current US$) of United Kingdom in 1963 to that in 1969?
Give a very brief answer. 1.31. What is the ratio of the Aid flow (current US$) of United States in 1963 to that in 1969?
Offer a terse response. 1.34. What is the ratio of the Aid flow (current US$) in Iceland in 1963 to that in 1969?
Your response must be concise. 0.18. What is the ratio of the Aid flow (current US$) in European Union in 1964 to that in 1965?
Keep it short and to the point. 0.86. What is the ratio of the Aid flow (current US$) in United Kingdom in 1964 to that in 1965?
Your answer should be very brief. 1.07. What is the ratio of the Aid flow (current US$) of United States in 1964 to that in 1965?
Make the answer very short. 0.8. What is the ratio of the Aid flow (current US$) in Iceland in 1964 to that in 1965?
Your response must be concise. 0.61. What is the ratio of the Aid flow (current US$) of European Union in 1964 to that in 1966?
Provide a short and direct response. 0.76. What is the ratio of the Aid flow (current US$) in United Kingdom in 1964 to that in 1966?
Offer a terse response. 1. What is the ratio of the Aid flow (current US$) of United States in 1964 to that in 1966?
Keep it short and to the point. 0.94. What is the ratio of the Aid flow (current US$) in Iceland in 1964 to that in 1966?
Make the answer very short. 0.38. What is the ratio of the Aid flow (current US$) in European Union in 1964 to that in 1967?
Provide a succinct answer. 0.82. What is the ratio of the Aid flow (current US$) in United Kingdom in 1964 to that in 1967?
Your response must be concise. 1.05. What is the ratio of the Aid flow (current US$) of Iceland in 1964 to that in 1967?
Make the answer very short. 0.43. What is the ratio of the Aid flow (current US$) of European Union in 1964 to that in 1968?
Provide a succinct answer. 0.5. What is the ratio of the Aid flow (current US$) of United Kingdom in 1964 to that in 1968?
Provide a short and direct response. 1.8. What is the ratio of the Aid flow (current US$) in United States in 1964 to that in 1968?
Offer a very short reply. 1.3. What is the ratio of the Aid flow (current US$) in Iceland in 1964 to that in 1968?
Offer a terse response. 0.34. What is the ratio of the Aid flow (current US$) of European Union in 1964 to that in 1969?
Keep it short and to the point. 0.67. What is the ratio of the Aid flow (current US$) in United Kingdom in 1964 to that in 1969?
Your answer should be very brief. 1.9. What is the ratio of the Aid flow (current US$) of United States in 1964 to that in 1969?
Provide a succinct answer. 1.3. What is the ratio of the Aid flow (current US$) of Iceland in 1964 to that in 1969?
Ensure brevity in your answer.  0.28. What is the ratio of the Aid flow (current US$) in European Union in 1965 to that in 1966?
Provide a succinct answer. 0.88. What is the ratio of the Aid flow (current US$) in United Kingdom in 1965 to that in 1966?
Provide a succinct answer. 0.93. What is the ratio of the Aid flow (current US$) in United States in 1965 to that in 1966?
Give a very brief answer. 1.18. What is the ratio of the Aid flow (current US$) in Iceland in 1965 to that in 1966?
Offer a very short reply. 0.63. What is the ratio of the Aid flow (current US$) of European Union in 1965 to that in 1967?
Offer a terse response. 0.96. What is the ratio of the Aid flow (current US$) in United Kingdom in 1965 to that in 1967?
Provide a succinct answer. 0.98. What is the ratio of the Aid flow (current US$) of United States in 1965 to that in 1967?
Your answer should be compact. 1.24. What is the ratio of the Aid flow (current US$) of Iceland in 1965 to that in 1967?
Provide a short and direct response. 0.7. What is the ratio of the Aid flow (current US$) of European Union in 1965 to that in 1968?
Your answer should be very brief. 0.58. What is the ratio of the Aid flow (current US$) of United Kingdom in 1965 to that in 1968?
Keep it short and to the point. 1.69. What is the ratio of the Aid flow (current US$) in United States in 1965 to that in 1968?
Keep it short and to the point. 1.63. What is the ratio of the Aid flow (current US$) in Iceland in 1965 to that in 1968?
Your response must be concise. 0.55. What is the ratio of the Aid flow (current US$) of European Union in 1965 to that in 1969?
Your answer should be very brief. 0.78. What is the ratio of the Aid flow (current US$) of United Kingdom in 1965 to that in 1969?
Make the answer very short. 1.78. What is the ratio of the Aid flow (current US$) of United States in 1965 to that in 1969?
Provide a short and direct response. 1.63. What is the ratio of the Aid flow (current US$) of Iceland in 1965 to that in 1969?
Provide a short and direct response. 0.46. What is the ratio of the Aid flow (current US$) in European Union in 1966 to that in 1967?
Provide a succinct answer. 1.08. What is the ratio of the Aid flow (current US$) in United Kingdom in 1966 to that in 1967?
Provide a short and direct response. 1.05. What is the ratio of the Aid flow (current US$) of United States in 1966 to that in 1967?
Keep it short and to the point. 1.05. What is the ratio of the Aid flow (current US$) in Iceland in 1966 to that in 1967?
Give a very brief answer. 1.11. What is the ratio of the Aid flow (current US$) of European Union in 1966 to that in 1968?
Your answer should be compact. 0.66. What is the ratio of the Aid flow (current US$) in United Kingdom in 1966 to that in 1968?
Keep it short and to the point. 1.81. What is the ratio of the Aid flow (current US$) in United States in 1966 to that in 1968?
Provide a succinct answer. 1.38. What is the ratio of the Aid flow (current US$) in Iceland in 1966 to that in 1968?
Provide a short and direct response. 0.88. What is the ratio of the Aid flow (current US$) in European Union in 1966 to that in 1969?
Make the answer very short. 0.88. What is the ratio of the Aid flow (current US$) in United Kingdom in 1966 to that in 1969?
Provide a short and direct response. 1.9. What is the ratio of the Aid flow (current US$) of United States in 1966 to that in 1969?
Give a very brief answer. 1.38. What is the ratio of the Aid flow (current US$) in Iceland in 1966 to that in 1969?
Provide a short and direct response. 0.73. What is the ratio of the Aid flow (current US$) of European Union in 1967 to that in 1968?
Provide a short and direct response. 0.61. What is the ratio of the Aid flow (current US$) of United Kingdom in 1967 to that in 1968?
Your answer should be compact. 1.73. What is the ratio of the Aid flow (current US$) of United States in 1967 to that in 1968?
Give a very brief answer. 1.31. What is the ratio of the Aid flow (current US$) of Iceland in 1967 to that in 1968?
Your answer should be compact. 0.79. What is the ratio of the Aid flow (current US$) of European Union in 1967 to that in 1969?
Your response must be concise. 0.81. What is the ratio of the Aid flow (current US$) of United Kingdom in 1967 to that in 1969?
Provide a succinct answer. 1.82. What is the ratio of the Aid flow (current US$) in United States in 1967 to that in 1969?
Your answer should be compact. 1.31. What is the ratio of the Aid flow (current US$) in Iceland in 1967 to that in 1969?
Your response must be concise. 0.66. What is the ratio of the Aid flow (current US$) of European Union in 1968 to that in 1969?
Offer a very short reply. 1.34. What is the ratio of the Aid flow (current US$) in United Kingdom in 1968 to that in 1969?
Offer a very short reply. 1.05. What is the ratio of the Aid flow (current US$) of United States in 1968 to that in 1969?
Provide a succinct answer. 1. What is the ratio of the Aid flow (current US$) of Iceland in 1968 to that in 1969?
Provide a short and direct response. 0.83. What is the difference between the highest and the second highest Aid flow (current US$) of European Union?
Provide a short and direct response. 2.70e+07. What is the difference between the highest and the second highest Aid flow (current US$) of United States?
Ensure brevity in your answer.  4.29e+07. What is the difference between the highest and the second highest Aid flow (current US$) of Iceland?
Offer a terse response. 8.00e+05. What is the difference between the highest and the lowest Aid flow (current US$) in European Union?
Your answer should be very brief. 6.69e+07. What is the difference between the highest and the lowest Aid flow (current US$) of United Kingdom?
Offer a very short reply. 6.70e+07. What is the difference between the highest and the lowest Aid flow (current US$) in United States?
Keep it short and to the point. 1.10e+08. What is the difference between the highest and the lowest Aid flow (current US$) in Iceland?
Offer a very short reply. 3.91e+06. 